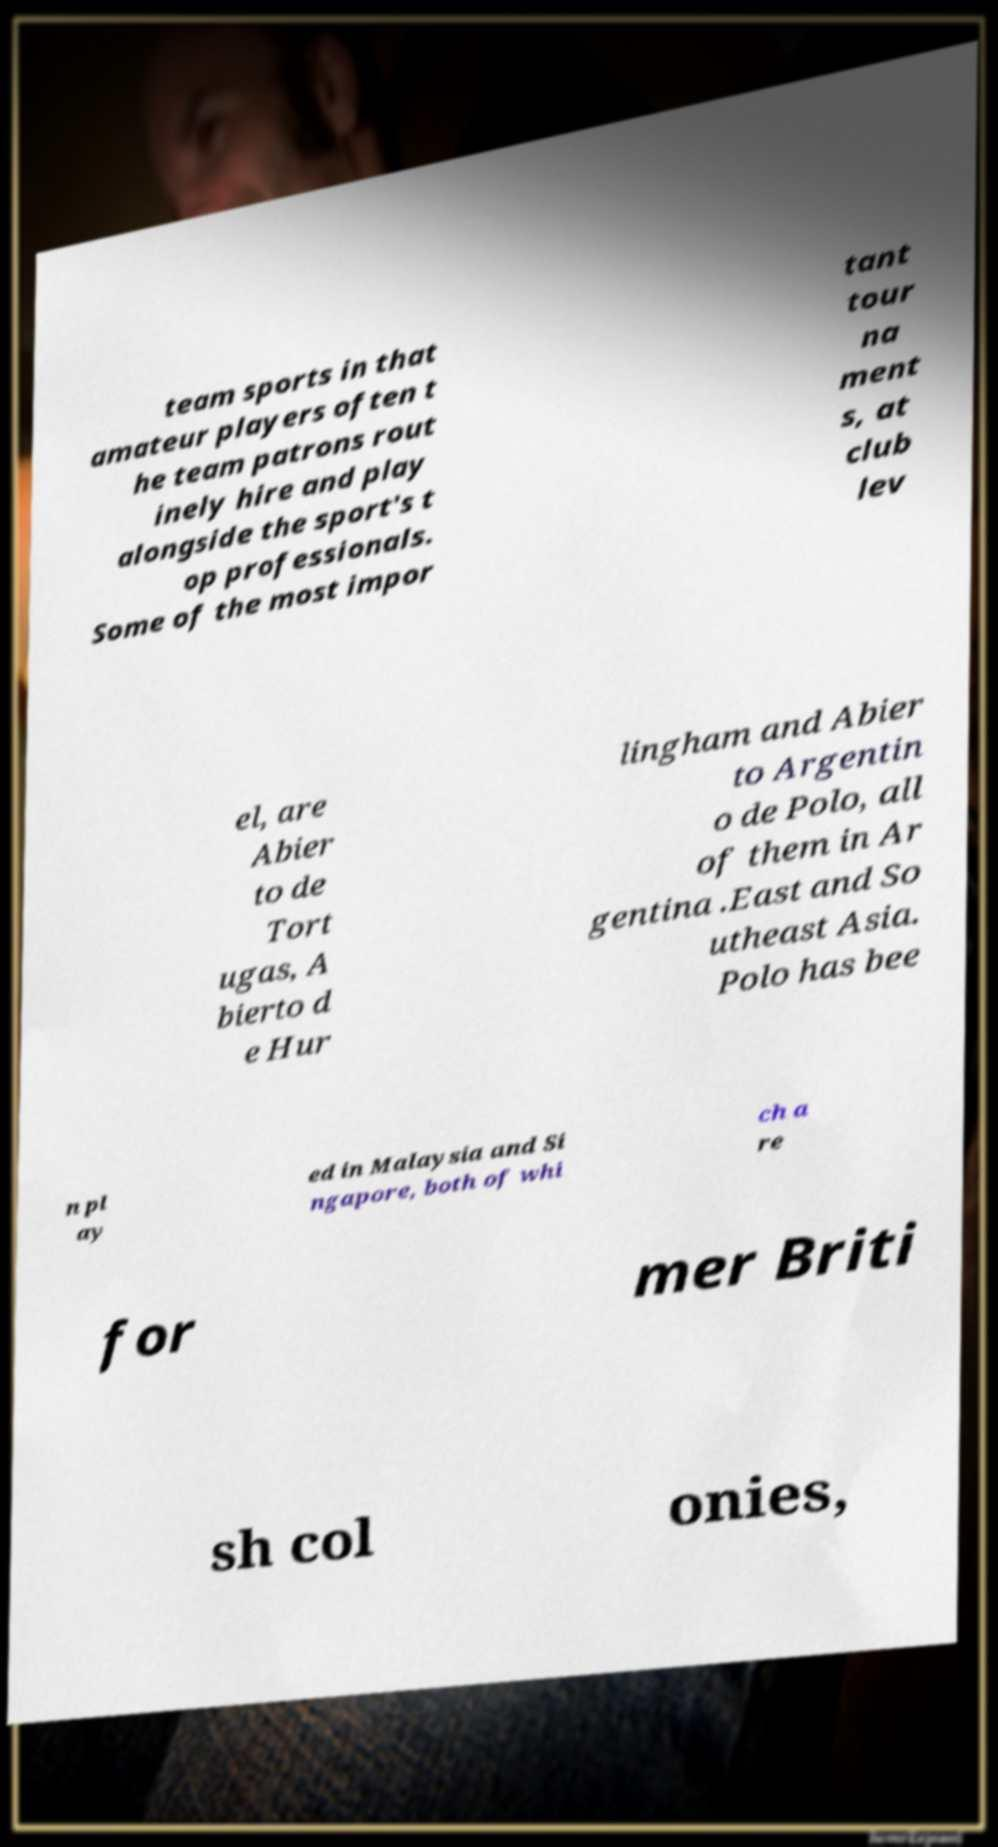Please identify and transcribe the text found in this image. team sports in that amateur players often t he team patrons rout inely hire and play alongside the sport's t op professionals. Some of the most impor tant tour na ment s, at club lev el, are Abier to de Tort ugas, A bierto d e Hur lingham and Abier to Argentin o de Polo, all of them in Ar gentina .East and So utheast Asia. Polo has bee n pl ay ed in Malaysia and Si ngapore, both of whi ch a re for mer Briti sh col onies, 